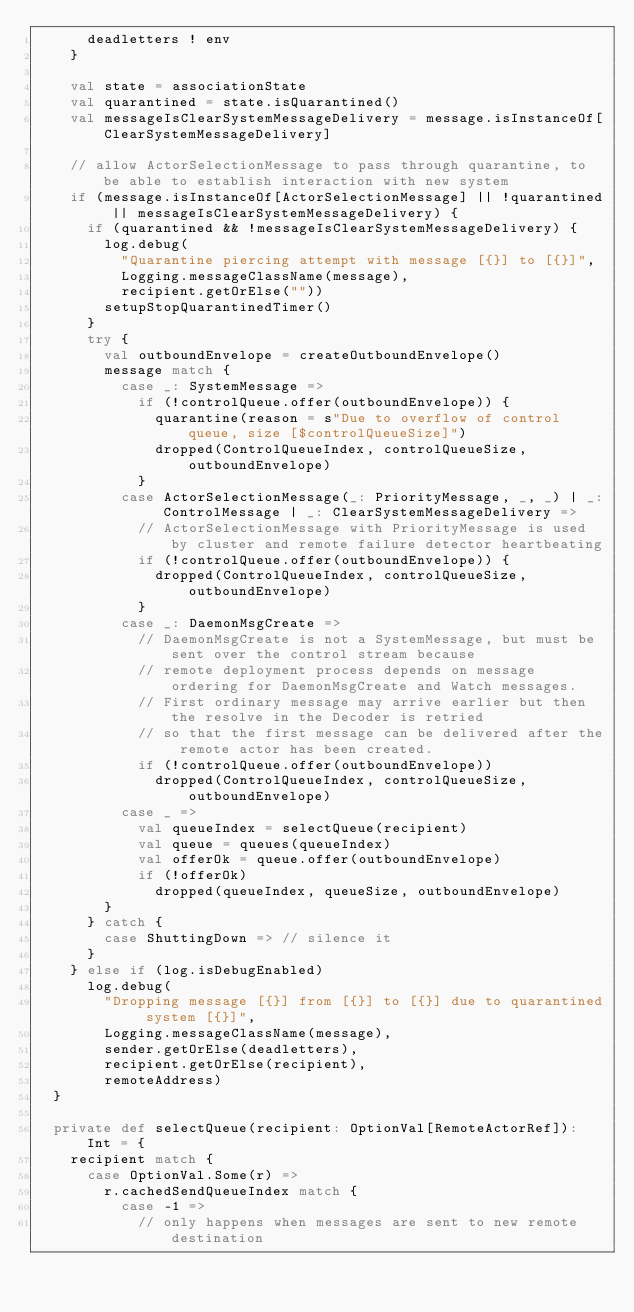<code> <loc_0><loc_0><loc_500><loc_500><_Scala_>      deadletters ! env
    }

    val state = associationState
    val quarantined = state.isQuarantined()
    val messageIsClearSystemMessageDelivery = message.isInstanceOf[ClearSystemMessageDelivery]

    // allow ActorSelectionMessage to pass through quarantine, to be able to establish interaction with new system
    if (message.isInstanceOf[ActorSelectionMessage] || !quarantined || messageIsClearSystemMessageDelivery) {
      if (quarantined && !messageIsClearSystemMessageDelivery) {
        log.debug(
          "Quarantine piercing attempt with message [{}] to [{}]",
          Logging.messageClassName(message),
          recipient.getOrElse(""))
        setupStopQuarantinedTimer()
      }
      try {
        val outboundEnvelope = createOutboundEnvelope()
        message match {
          case _: SystemMessage =>
            if (!controlQueue.offer(outboundEnvelope)) {
              quarantine(reason = s"Due to overflow of control queue, size [$controlQueueSize]")
              dropped(ControlQueueIndex, controlQueueSize, outboundEnvelope)
            }
          case ActorSelectionMessage(_: PriorityMessage, _, _) | _: ControlMessage | _: ClearSystemMessageDelivery =>
            // ActorSelectionMessage with PriorityMessage is used by cluster and remote failure detector heartbeating
            if (!controlQueue.offer(outboundEnvelope)) {
              dropped(ControlQueueIndex, controlQueueSize, outboundEnvelope)
            }
          case _: DaemonMsgCreate =>
            // DaemonMsgCreate is not a SystemMessage, but must be sent over the control stream because
            // remote deployment process depends on message ordering for DaemonMsgCreate and Watch messages.
            // First ordinary message may arrive earlier but then the resolve in the Decoder is retried
            // so that the first message can be delivered after the remote actor has been created.
            if (!controlQueue.offer(outboundEnvelope))
              dropped(ControlQueueIndex, controlQueueSize, outboundEnvelope)
          case _ =>
            val queueIndex = selectQueue(recipient)
            val queue = queues(queueIndex)
            val offerOk = queue.offer(outboundEnvelope)
            if (!offerOk)
              dropped(queueIndex, queueSize, outboundEnvelope)
        }
      } catch {
        case ShuttingDown => // silence it
      }
    } else if (log.isDebugEnabled)
      log.debug(
        "Dropping message [{}] from [{}] to [{}] due to quarantined system [{}]",
        Logging.messageClassName(message),
        sender.getOrElse(deadletters),
        recipient.getOrElse(recipient),
        remoteAddress)
  }

  private def selectQueue(recipient: OptionVal[RemoteActorRef]): Int = {
    recipient match {
      case OptionVal.Some(r) =>
        r.cachedSendQueueIndex match {
          case -1 =>
            // only happens when messages are sent to new remote destination</code> 